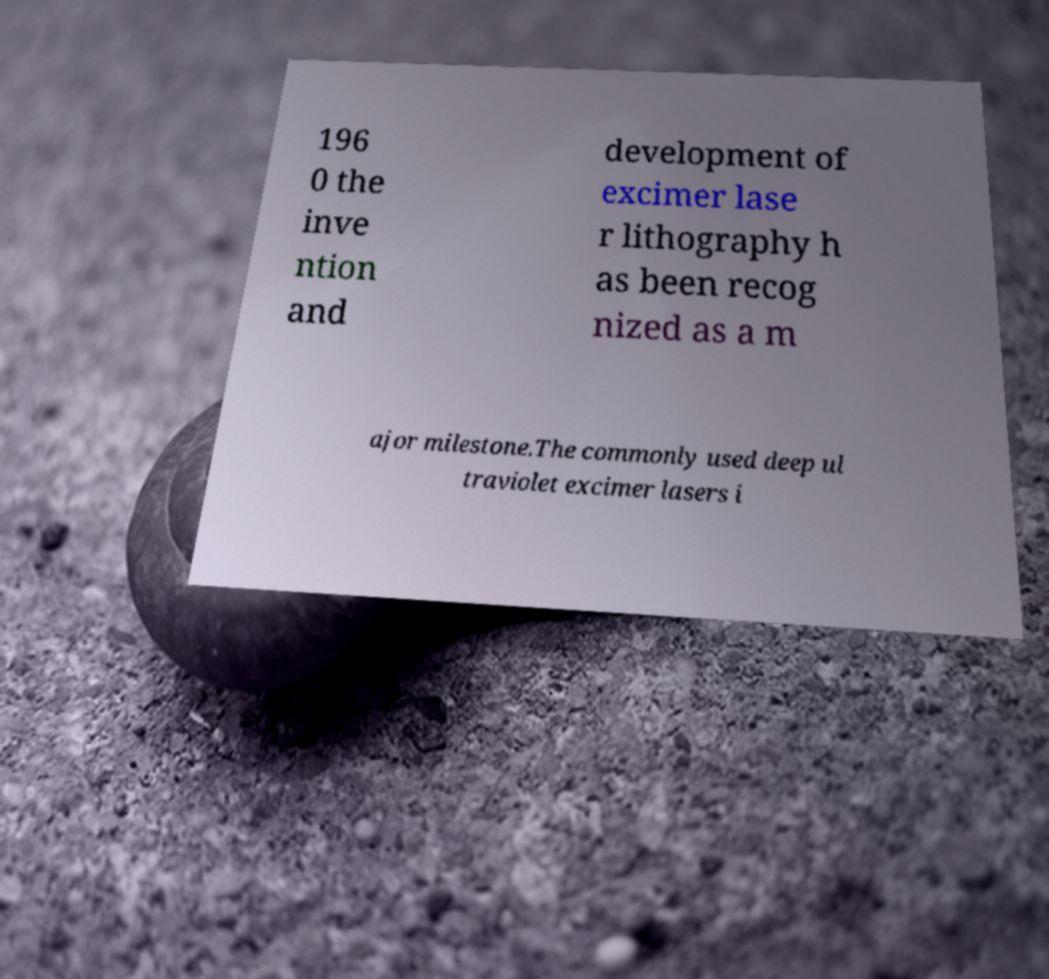For documentation purposes, I need the text within this image transcribed. Could you provide that? 196 0 the inve ntion and development of excimer lase r lithography h as been recog nized as a m ajor milestone.The commonly used deep ul traviolet excimer lasers i 